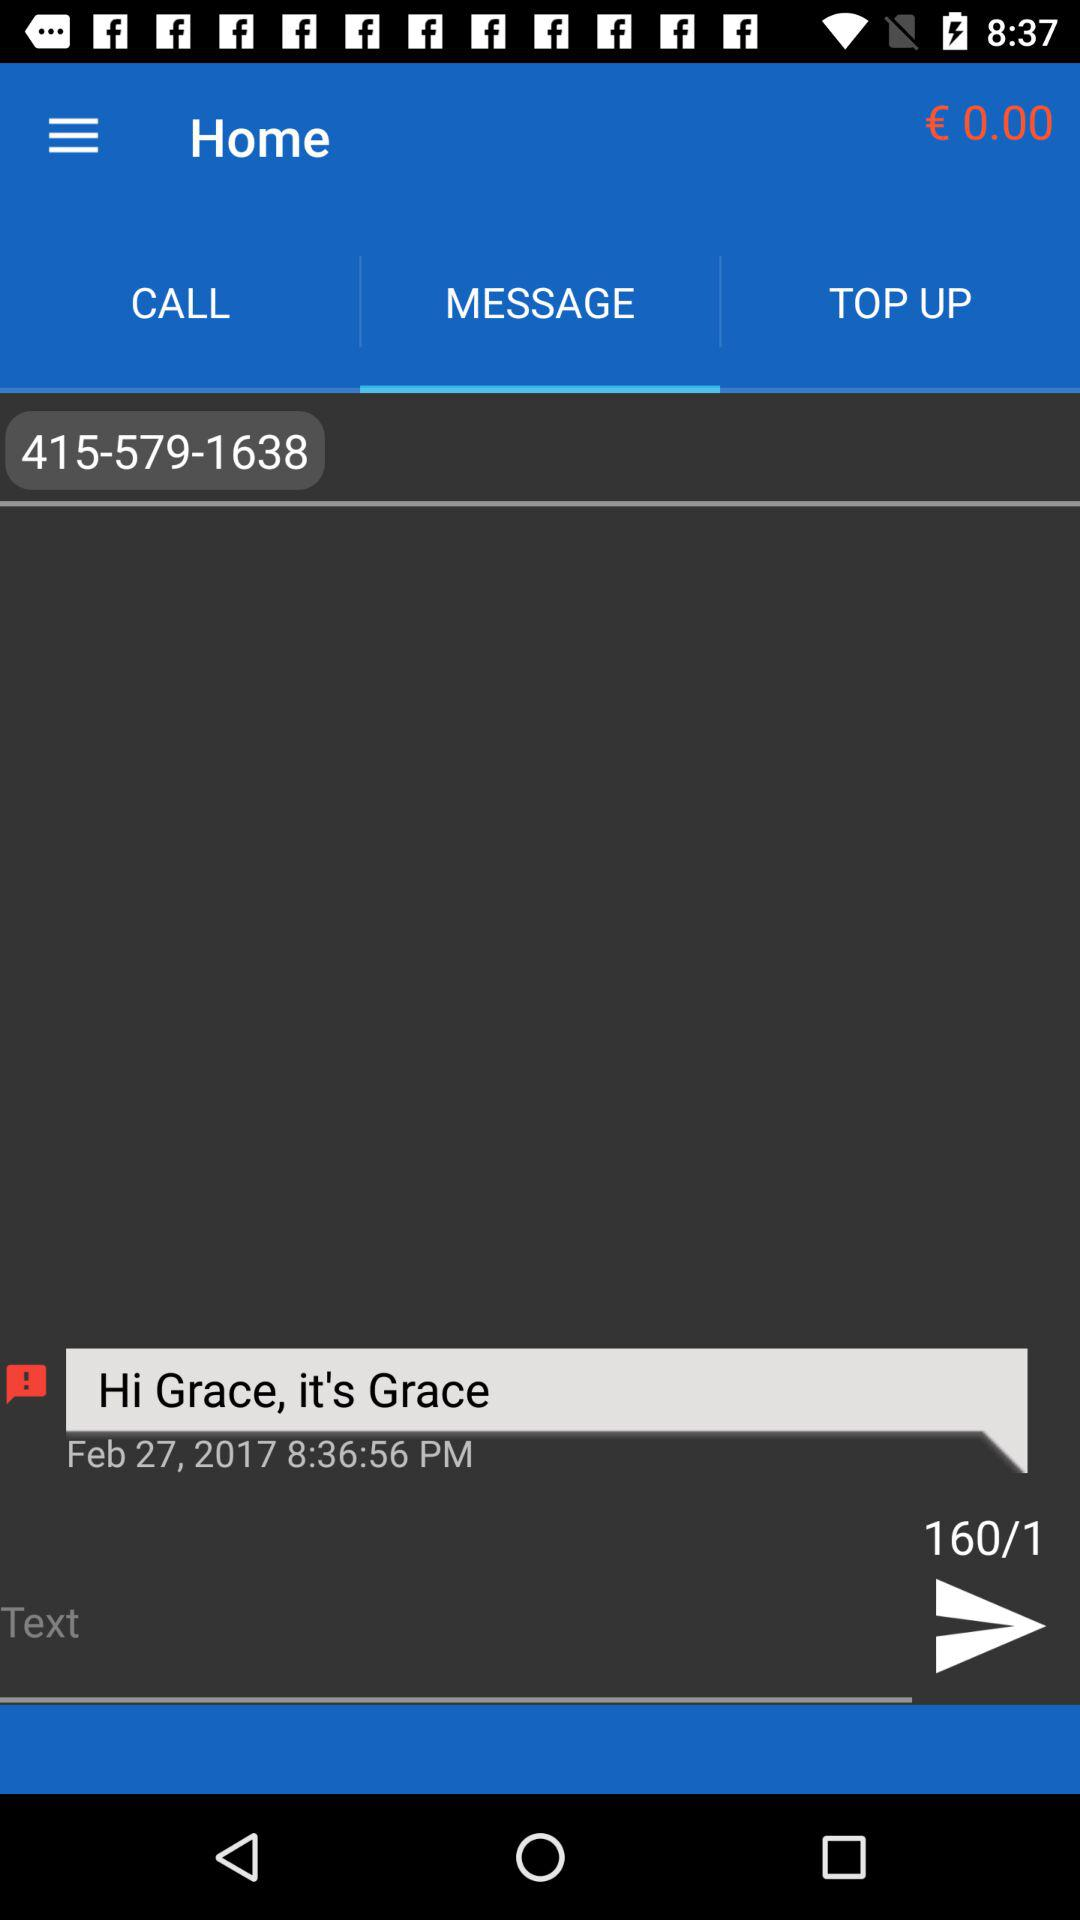On what date did the user try to send the message? The user tried to send the message on February 27, 2017. 